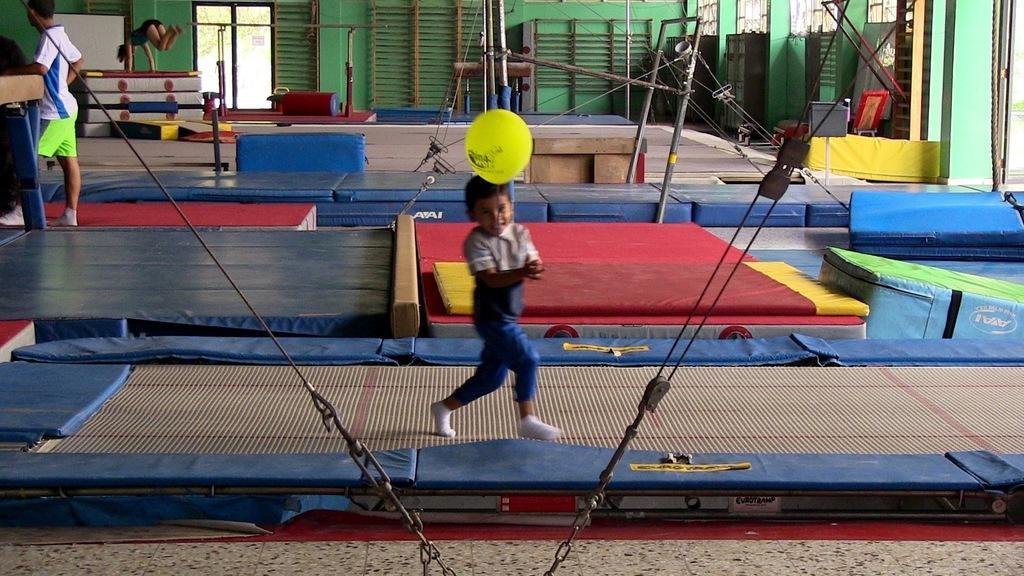In one or two sentences, can you explain what this image depicts? In this image we can see a kid playing with ball at the foreground of the image and at the background of the image there is person standing and some person doing flip on trampoline flip, there is wall and doors. 